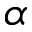<formula> <loc_0><loc_0><loc_500><loc_500>\alpha</formula> 